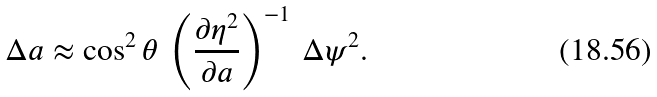Convert formula to latex. <formula><loc_0><loc_0><loc_500><loc_500>\Delta a \approx \cos ^ { 2 } \theta \, \left ( \frac { \partial \eta ^ { 2 } } { \partial a } \right ) ^ { - 1 } \, \Delta \psi ^ { 2 } .</formula> 